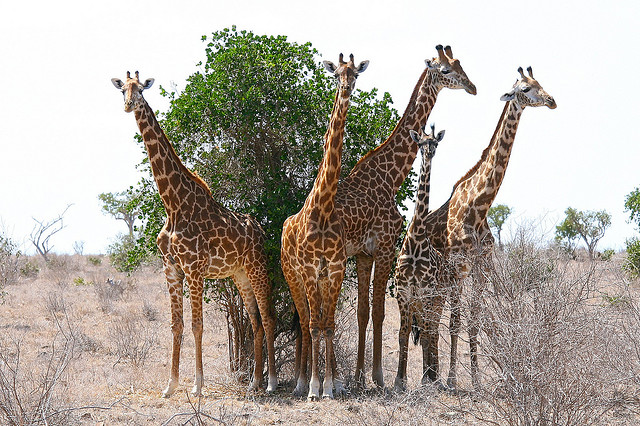<image>What kind of tree is the giraffe under? I don't know what kind of tree the giraffe is under. It could be an oak, elm, or broadleaf tree. What kind of tree is the giraffe under? I don't know what kind of tree the giraffe is under. It can be oak, elm, or another type of broadleaf tree. 